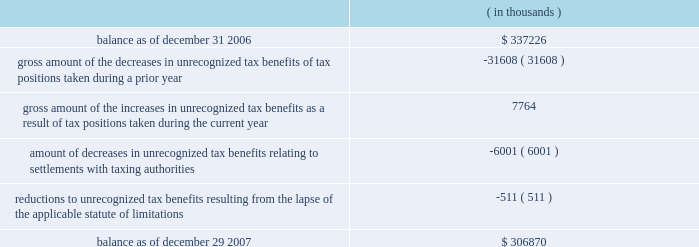The changes in the gross amount of unrecognized tax benefits for the year ended december 29 , 2007 are as follows: .
As of december 29 , 2007 , $ 228.4 million of unrecognized tax benefits would , if recognized , reduce the effective tax rate , as compared to $ 232.1 million as of december 31 , 2006 , the first day of cadence 2019s fiscal year .
The total amounts of interest and penalties recognized in the consolidated income statement for the year ended december 29 , 2007 resulted in net tax benefits of $ 11.1 million and $ 0.4 million , respectively , primarily due to the effective settlement of tax audits during the year .
The total amounts of gross accrued interest and penalties recognized in the consolidated balance sheets as of december 29 , 2007 , were $ 47.9 million and $ 9.7 million , respectively as compared to $ 65.8 million and $ 10.1 million , respectively as of december 31 , 2006 .
Note 9 .
Acquisitions for each of the acquisitions described below , the results of operations and the estimated fair value of the assets acquired and liabilities assumed have been included in cadence 2019s consolidated financial statements from the date of the acquisition .
Comparative pro forma financial information for all 2007 , 2006 and 2005 acquisitions have not been presented because the results of operations were not material to cadence 2019s consolidated financial statements .
2007 acquisitions during 2007 , cadence acquired invarium , inc. , a san jose-based developer of advanced lithography-modeling and pattern-synthesis technology , and clear shape technologies , inc. , a san jose-based design for manufacturing technology company specializing in design-side solutions to minimize yield loss for advanced semiconductor integrated circuits .
Cadence acquired these two companies for an aggregate purchase price of $ 75.5 million , which included the payment of cash , the fair value of assumed options and acquisition costs .
The $ 45.7 million of goodwill recorded in connection with these acquisitions is not expected to be deductible for income tax purposes .
Prior to acquiring clear shape technologies , inc. , cadence had an investment of $ 2.0 million in the company , representing a 12% ( 12 % ) ownership interest , which had been accounted for under the cost method of accounting .
In accordance with sfas no .
141 , 201cbusiness combinations , 201d cadence accounted for this acquisition as a step acquisition .
Subsequent adjustments to the purchase price of these acquired companies are included in the 201cother 201d line of the changes of goodwill table in note 10 below .
2006 acquisition in march 2006 , cadence acquired a company for an aggregate initial purchase price of $ 25.8 million , which included the payment of cash , the fair value of assumed options and acquisition costs .
The preliminary allocation of the purchase price was recorded as $ 17.4 million of goodwill , $ 9.4 million of identifiable intangible assets and $ ( 1.0 ) million of net liabilities .
The $ 17.4 million of goodwill recorded in connection with this acquisition is not expected to be deductible for income tax purposes .
Subsequent adjustments to the purchase price of this acquired company are included in the 201cother 201d line of the changes of goodwill table in note 10 below. .
What percentage of the aggregate purchase price for the company in 2006 is goodwill? 
Computations: (17.4 / 25.8)
Answer: 0.67442. 